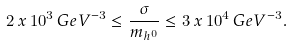Convert formula to latex. <formula><loc_0><loc_0><loc_500><loc_500>2 \, x \, 1 0 ^ { 3 } \, G e V ^ { - 3 } \leq \frac { \sigma } { m _ { h ^ { 0 } } } \leq 3 \, x \, 1 0 ^ { 4 } \, G e V ^ { - 3 } .</formula> 